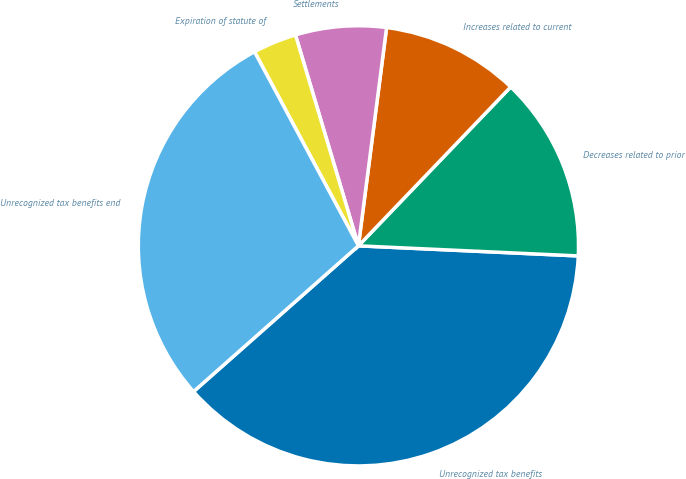Convert chart to OTSL. <chart><loc_0><loc_0><loc_500><loc_500><pie_chart><fcel>Unrecognized tax benefits<fcel>Decreases related to prior<fcel>Increases related to current<fcel>Settlements<fcel>Expiration of statute of<fcel>Unrecognized tax benefits end<nl><fcel>37.75%<fcel>13.57%<fcel>10.12%<fcel>6.66%<fcel>3.21%<fcel>28.7%<nl></chart> 